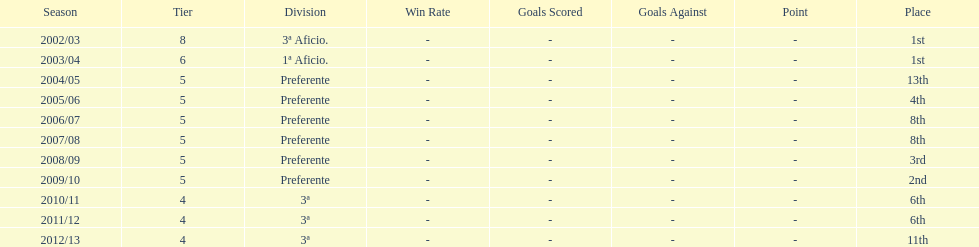Which division has the largest number of ranks? Preferente. 